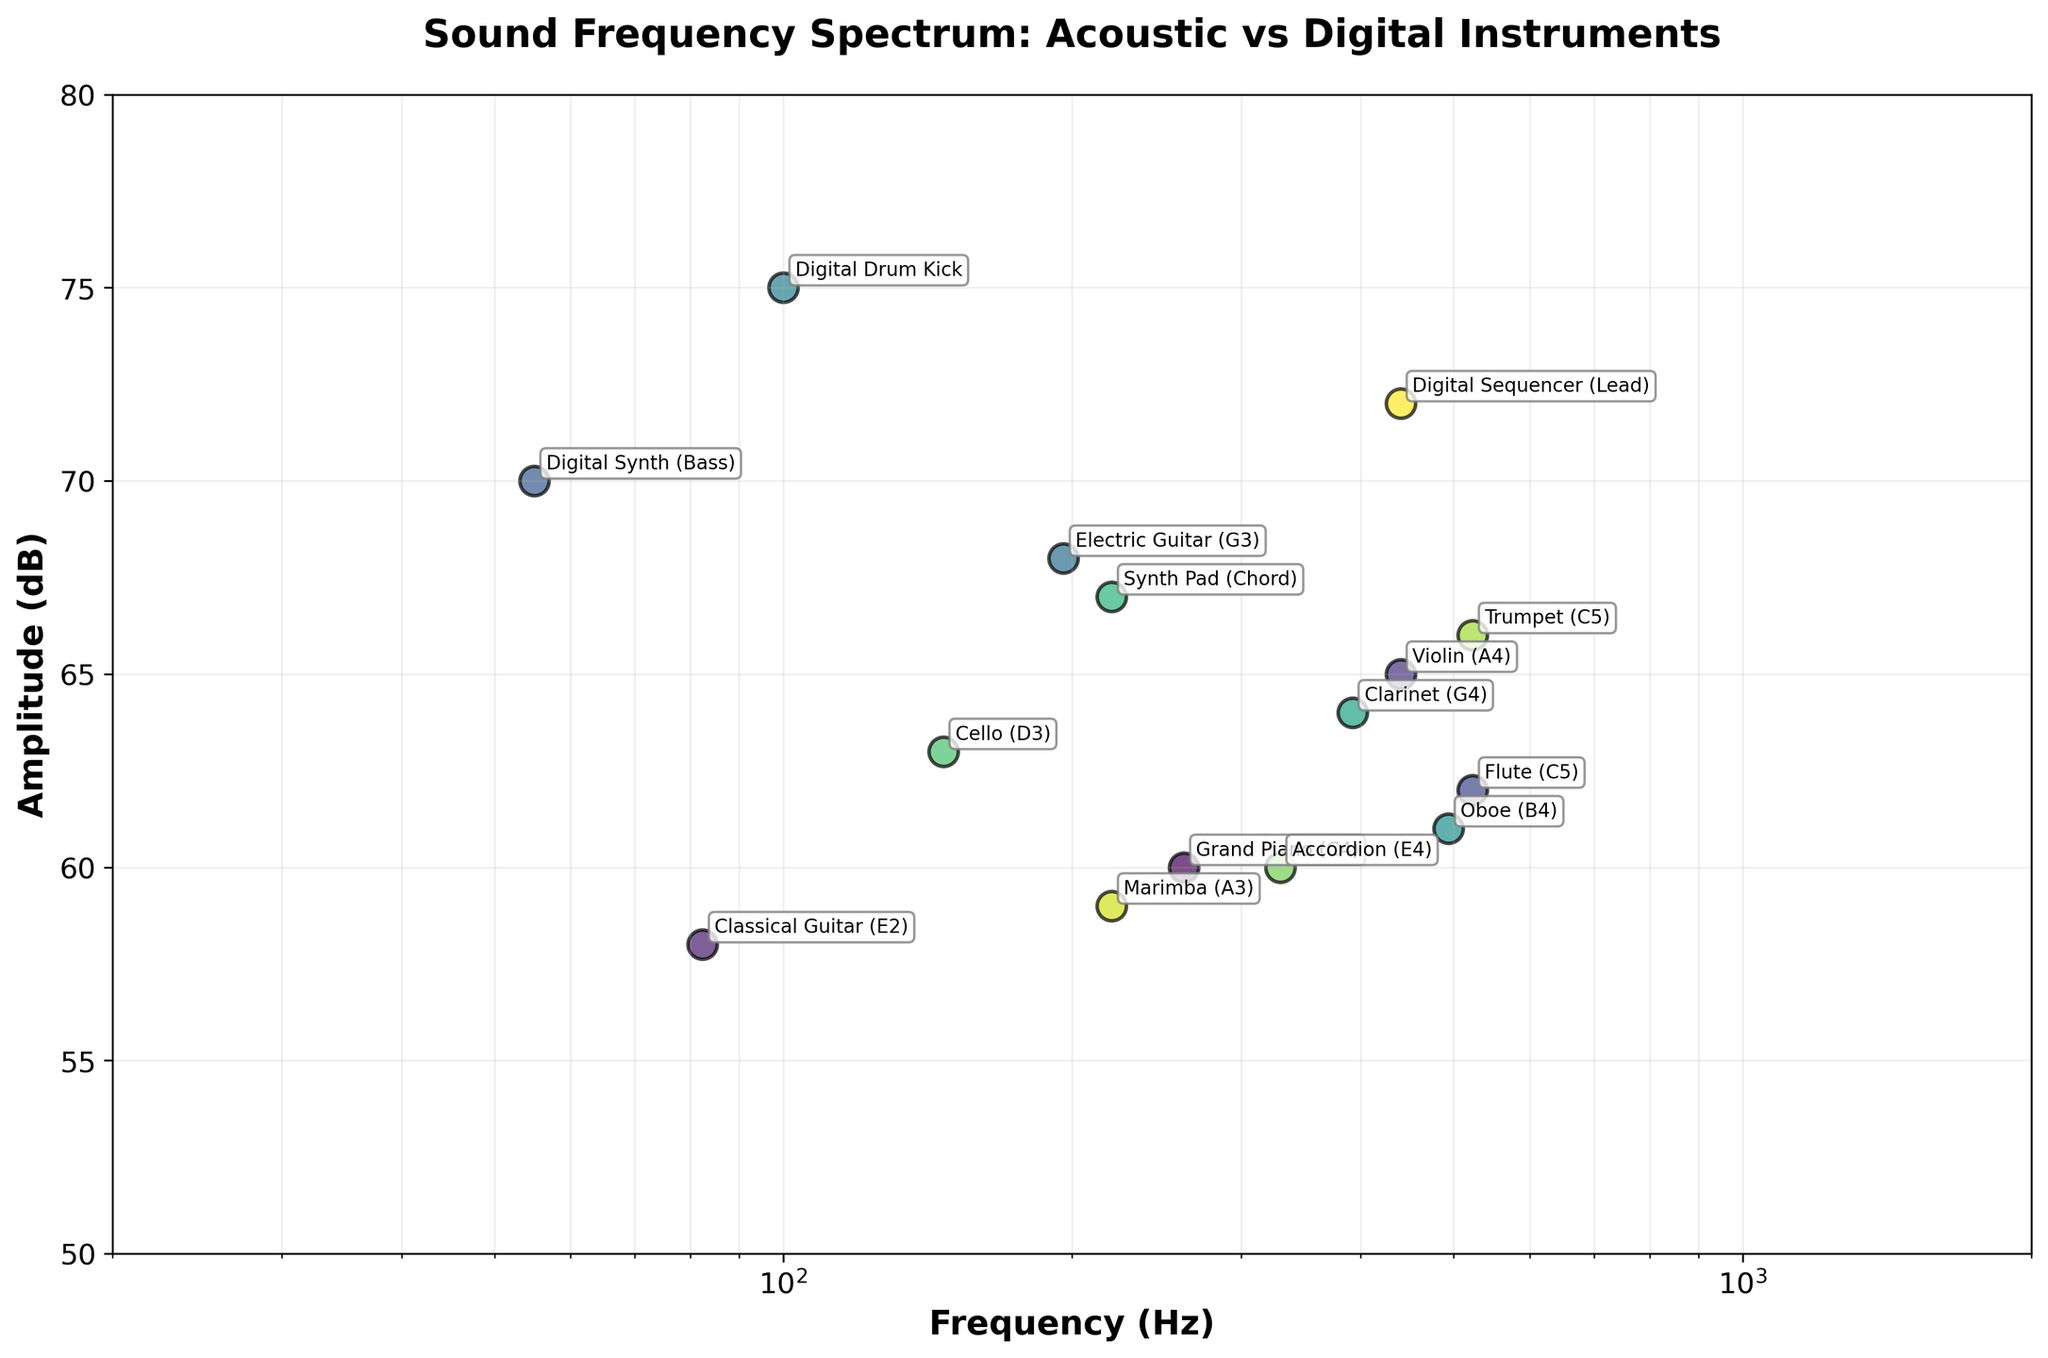How many data points are plotted in the figure? We can count the labeled instruments in the scatter plot one by one to determine the total number of data points.
Answer: 15 What is the title of the figure? By looking at the top part of the plot, we can read the title.
Answer: Sound Frequency Spectrum: Acoustic vs Digital Instruments Which instrument has the highest amplitude? We identify the data point positioned highest on the y-axis, representing amplitude in dB.
Answer: Digital Drum Kick What is the amplitude difference between the Flute and the Accordion? Find the amplitude values for both instruments, then subtract the lower value from the higher value. Flute has 62 dB and Accordion has 60 dB, so 62 - 60.
Answer: 2 dB Which instrument has the lowest frequency? Identify the data point furthest to the left on the x-axis, which represents frequency in Hz.
Answer: Digital Synth (Bass) What frequency range is covered by the instruments in the plot? Determine the minimum and maximum frequency values among all data points. The lowest is 55 Hz (Digital Synth Bass) and the highest is 523.25 Hz (Flute, Trumpet).
Answer: 55 Hz to 523.25 Hz How many instruments have a frequency greater than 400 Hz? Count the number of data points with frequencies above 400 Hz using the x-axis. Instruments: Violin, Flute, Digital Sequencer (Lead), Oboe, Trumpet.
Answer: 5 Compare the amplitude of the Violin and Digital Sequencer (Lead). Which is higher and by how much? Identify the amplitude values for both instruments and calculate the difference. Violin has 65 dB, Digital Sequencer (Lead) has 72 dB, so 72 - 65.
Answer: Digital Sequencer (Lead) by 7 dB What is the frequency of the instrument labeled "Electric Guitar"? Locate the Electric Guitar data point and read its x-axis value.
Answer: 196 Hz Which instrument has the highest amplitude among acoustic instruments? Filter out digital instruments and examine only acoustic ones to find the highest y-axis value.
Answer: Violin 